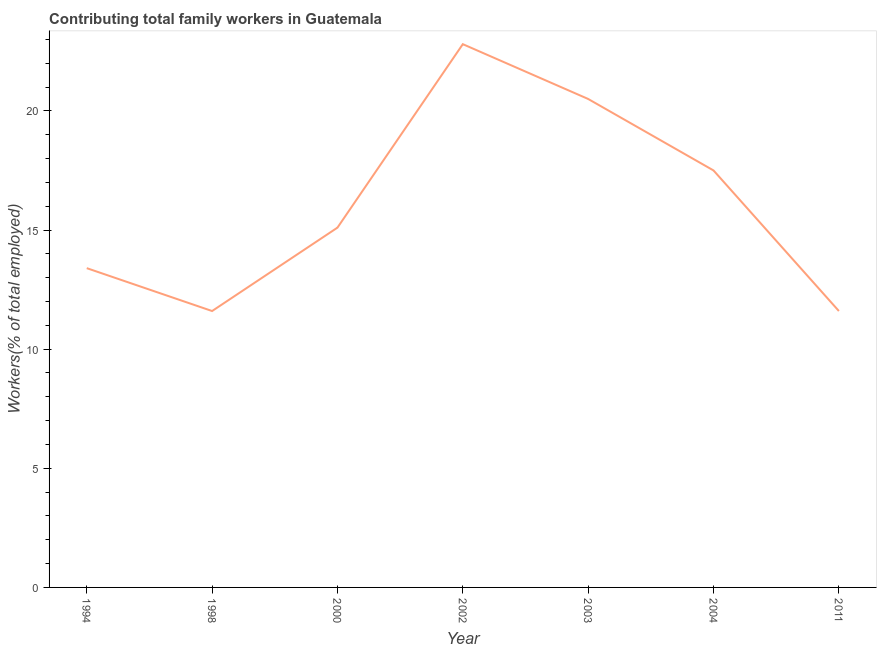What is the contributing family workers in 1994?
Offer a very short reply. 13.4. Across all years, what is the maximum contributing family workers?
Your response must be concise. 22.8. Across all years, what is the minimum contributing family workers?
Your response must be concise. 11.6. In which year was the contributing family workers maximum?
Offer a very short reply. 2002. What is the sum of the contributing family workers?
Your response must be concise. 112.5. What is the difference between the contributing family workers in 2000 and 2002?
Ensure brevity in your answer.  -7.7. What is the average contributing family workers per year?
Ensure brevity in your answer.  16.07. What is the median contributing family workers?
Make the answer very short. 15.1. In how many years, is the contributing family workers greater than 18 %?
Your answer should be very brief. 2. What is the ratio of the contributing family workers in 1998 to that in 2003?
Ensure brevity in your answer.  0.57. Is the contributing family workers in 2000 less than that in 2002?
Your answer should be compact. Yes. What is the difference between the highest and the second highest contributing family workers?
Ensure brevity in your answer.  2.3. What is the difference between the highest and the lowest contributing family workers?
Your answer should be very brief. 11.2. Does the contributing family workers monotonically increase over the years?
Provide a succinct answer. No. How many lines are there?
Make the answer very short. 1. How many years are there in the graph?
Offer a very short reply. 7. What is the difference between two consecutive major ticks on the Y-axis?
Offer a very short reply. 5. Does the graph contain any zero values?
Your response must be concise. No. What is the title of the graph?
Your answer should be compact. Contributing total family workers in Guatemala. What is the label or title of the X-axis?
Your response must be concise. Year. What is the label or title of the Y-axis?
Provide a short and direct response. Workers(% of total employed). What is the Workers(% of total employed) of 1994?
Offer a terse response. 13.4. What is the Workers(% of total employed) of 1998?
Your answer should be compact. 11.6. What is the Workers(% of total employed) in 2000?
Provide a short and direct response. 15.1. What is the Workers(% of total employed) of 2002?
Ensure brevity in your answer.  22.8. What is the Workers(% of total employed) of 2003?
Your response must be concise. 20.5. What is the Workers(% of total employed) of 2011?
Ensure brevity in your answer.  11.6. What is the difference between the Workers(% of total employed) in 1994 and 2004?
Provide a succinct answer. -4.1. What is the difference between the Workers(% of total employed) in 1998 and 2002?
Keep it short and to the point. -11.2. What is the difference between the Workers(% of total employed) in 1998 and 2011?
Your answer should be very brief. 0. What is the difference between the Workers(% of total employed) in 2000 and 2004?
Ensure brevity in your answer.  -2.4. What is the difference between the Workers(% of total employed) in 2000 and 2011?
Ensure brevity in your answer.  3.5. What is the difference between the Workers(% of total employed) in 2002 and 2003?
Your answer should be very brief. 2.3. What is the difference between the Workers(% of total employed) in 2003 and 2004?
Your answer should be compact. 3. What is the difference between the Workers(% of total employed) in 2003 and 2011?
Give a very brief answer. 8.9. What is the ratio of the Workers(% of total employed) in 1994 to that in 1998?
Provide a short and direct response. 1.16. What is the ratio of the Workers(% of total employed) in 1994 to that in 2000?
Offer a very short reply. 0.89. What is the ratio of the Workers(% of total employed) in 1994 to that in 2002?
Keep it short and to the point. 0.59. What is the ratio of the Workers(% of total employed) in 1994 to that in 2003?
Your answer should be very brief. 0.65. What is the ratio of the Workers(% of total employed) in 1994 to that in 2004?
Offer a very short reply. 0.77. What is the ratio of the Workers(% of total employed) in 1994 to that in 2011?
Make the answer very short. 1.16. What is the ratio of the Workers(% of total employed) in 1998 to that in 2000?
Your response must be concise. 0.77. What is the ratio of the Workers(% of total employed) in 1998 to that in 2002?
Ensure brevity in your answer.  0.51. What is the ratio of the Workers(% of total employed) in 1998 to that in 2003?
Make the answer very short. 0.57. What is the ratio of the Workers(% of total employed) in 1998 to that in 2004?
Offer a very short reply. 0.66. What is the ratio of the Workers(% of total employed) in 2000 to that in 2002?
Give a very brief answer. 0.66. What is the ratio of the Workers(% of total employed) in 2000 to that in 2003?
Offer a terse response. 0.74. What is the ratio of the Workers(% of total employed) in 2000 to that in 2004?
Give a very brief answer. 0.86. What is the ratio of the Workers(% of total employed) in 2000 to that in 2011?
Provide a short and direct response. 1.3. What is the ratio of the Workers(% of total employed) in 2002 to that in 2003?
Offer a terse response. 1.11. What is the ratio of the Workers(% of total employed) in 2002 to that in 2004?
Provide a succinct answer. 1.3. What is the ratio of the Workers(% of total employed) in 2002 to that in 2011?
Ensure brevity in your answer.  1.97. What is the ratio of the Workers(% of total employed) in 2003 to that in 2004?
Ensure brevity in your answer.  1.17. What is the ratio of the Workers(% of total employed) in 2003 to that in 2011?
Keep it short and to the point. 1.77. What is the ratio of the Workers(% of total employed) in 2004 to that in 2011?
Ensure brevity in your answer.  1.51. 